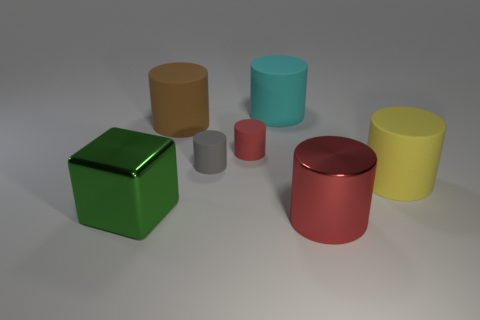The big metal cylinder is what color?
Provide a succinct answer. Red. There is a shiny thing on the right side of the brown rubber cylinder; how many gray matte things are to the right of it?
Provide a succinct answer. 0. How big is the rubber cylinder that is both in front of the red rubber object and left of the cyan matte cylinder?
Offer a terse response. Small. What is the material of the red object to the right of the cyan cylinder?
Provide a succinct answer. Metal. Is there another large rubber object of the same shape as the red matte object?
Provide a short and direct response. Yes. How many small rubber objects have the same shape as the big red shiny thing?
Provide a succinct answer. 2. Is the size of the matte cylinder to the right of the metal cylinder the same as the red object on the left side of the cyan thing?
Make the answer very short. No. There is a large metal thing behind the object in front of the large green thing; what shape is it?
Provide a succinct answer. Cube. Are there an equal number of large red metal cylinders that are in front of the big shiny cylinder and yellow cylinders?
Provide a succinct answer. No. What is the red thing that is right of the red cylinder that is behind the rubber cylinder that is on the right side of the large red object made of?
Your answer should be compact. Metal. 